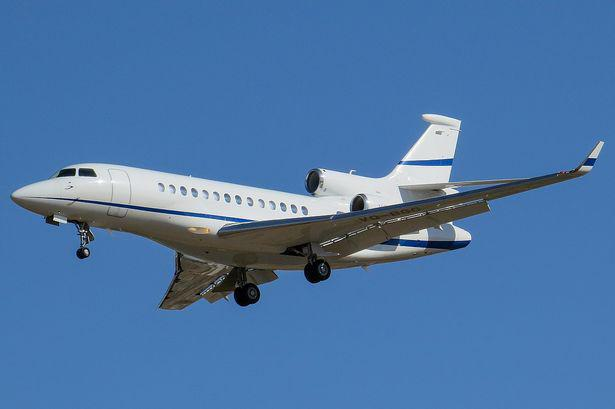What model of airplane is shown in this image? This appears to be a Dassault Falcon 7X, a popular model among business jets for its range and luxury features. 